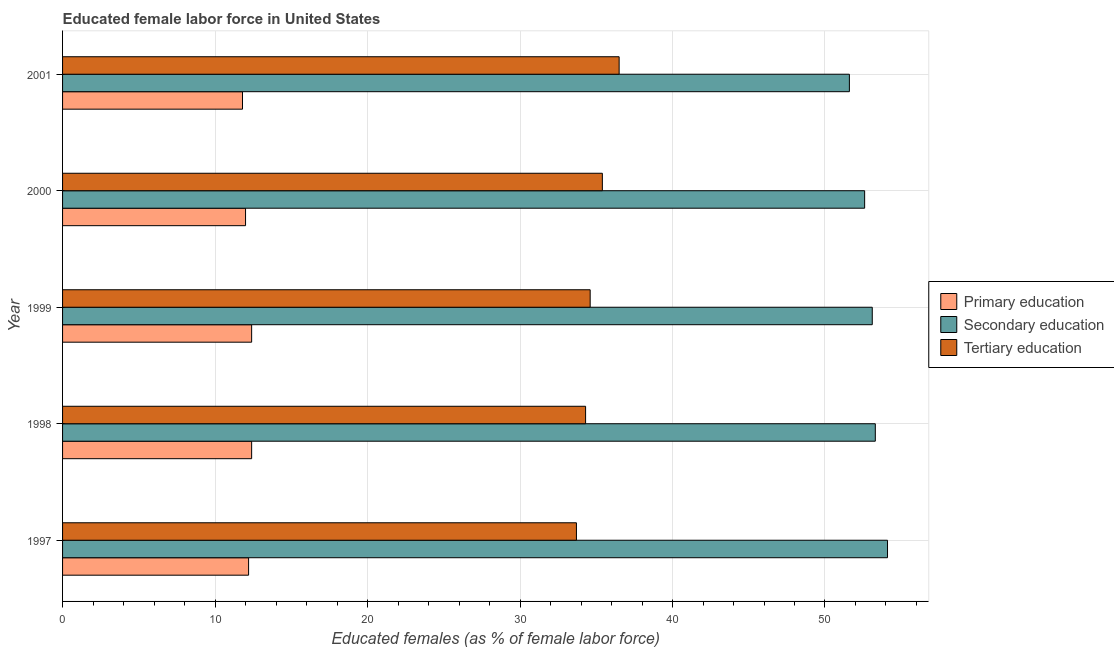How many different coloured bars are there?
Your answer should be very brief. 3. Are the number of bars per tick equal to the number of legend labels?
Provide a short and direct response. Yes. How many bars are there on the 5th tick from the top?
Your answer should be compact. 3. What is the percentage of female labor force who received secondary education in 1998?
Keep it short and to the point. 53.3. Across all years, what is the maximum percentage of female labor force who received tertiary education?
Offer a terse response. 36.5. Across all years, what is the minimum percentage of female labor force who received primary education?
Give a very brief answer. 11.8. In which year was the percentage of female labor force who received secondary education maximum?
Provide a succinct answer. 1997. In which year was the percentage of female labor force who received tertiary education minimum?
Your answer should be compact. 1997. What is the total percentage of female labor force who received secondary education in the graph?
Your answer should be very brief. 264.7. What is the difference between the percentage of female labor force who received primary education in 1997 and the percentage of female labor force who received secondary education in 1998?
Ensure brevity in your answer.  -41.1. What is the average percentage of female labor force who received primary education per year?
Your response must be concise. 12.16. In the year 1997, what is the difference between the percentage of female labor force who received primary education and percentage of female labor force who received secondary education?
Your answer should be very brief. -41.9. Is the difference between the percentage of female labor force who received primary education in 1997 and 1998 greater than the difference between the percentage of female labor force who received tertiary education in 1997 and 1998?
Provide a succinct answer. Yes. What does the 2nd bar from the bottom in 1997 represents?
Ensure brevity in your answer.  Secondary education. Is it the case that in every year, the sum of the percentage of female labor force who received primary education and percentage of female labor force who received secondary education is greater than the percentage of female labor force who received tertiary education?
Ensure brevity in your answer.  Yes. How many bars are there?
Provide a short and direct response. 15. Are all the bars in the graph horizontal?
Provide a short and direct response. Yes. What is the difference between two consecutive major ticks on the X-axis?
Give a very brief answer. 10. Are the values on the major ticks of X-axis written in scientific E-notation?
Your response must be concise. No. Does the graph contain any zero values?
Give a very brief answer. No. How many legend labels are there?
Ensure brevity in your answer.  3. How are the legend labels stacked?
Ensure brevity in your answer.  Vertical. What is the title of the graph?
Ensure brevity in your answer.  Educated female labor force in United States. What is the label or title of the X-axis?
Provide a succinct answer. Educated females (as % of female labor force). What is the label or title of the Y-axis?
Your answer should be very brief. Year. What is the Educated females (as % of female labor force) in Primary education in 1997?
Your answer should be very brief. 12.2. What is the Educated females (as % of female labor force) of Secondary education in 1997?
Your answer should be very brief. 54.1. What is the Educated females (as % of female labor force) of Tertiary education in 1997?
Your answer should be very brief. 33.7. What is the Educated females (as % of female labor force) in Primary education in 1998?
Offer a terse response. 12.4. What is the Educated females (as % of female labor force) in Secondary education in 1998?
Ensure brevity in your answer.  53.3. What is the Educated females (as % of female labor force) in Tertiary education in 1998?
Offer a very short reply. 34.3. What is the Educated females (as % of female labor force) of Primary education in 1999?
Your response must be concise. 12.4. What is the Educated females (as % of female labor force) of Secondary education in 1999?
Provide a short and direct response. 53.1. What is the Educated females (as % of female labor force) of Tertiary education in 1999?
Offer a terse response. 34.6. What is the Educated females (as % of female labor force) in Secondary education in 2000?
Offer a very short reply. 52.6. What is the Educated females (as % of female labor force) in Tertiary education in 2000?
Ensure brevity in your answer.  35.4. What is the Educated females (as % of female labor force) of Primary education in 2001?
Give a very brief answer. 11.8. What is the Educated females (as % of female labor force) of Secondary education in 2001?
Make the answer very short. 51.6. What is the Educated females (as % of female labor force) of Tertiary education in 2001?
Provide a succinct answer. 36.5. Across all years, what is the maximum Educated females (as % of female labor force) of Primary education?
Ensure brevity in your answer.  12.4. Across all years, what is the maximum Educated females (as % of female labor force) in Secondary education?
Give a very brief answer. 54.1. Across all years, what is the maximum Educated females (as % of female labor force) in Tertiary education?
Your response must be concise. 36.5. Across all years, what is the minimum Educated females (as % of female labor force) in Primary education?
Offer a terse response. 11.8. Across all years, what is the minimum Educated females (as % of female labor force) in Secondary education?
Keep it short and to the point. 51.6. Across all years, what is the minimum Educated females (as % of female labor force) in Tertiary education?
Provide a succinct answer. 33.7. What is the total Educated females (as % of female labor force) of Primary education in the graph?
Make the answer very short. 60.8. What is the total Educated females (as % of female labor force) of Secondary education in the graph?
Provide a succinct answer. 264.7. What is the total Educated females (as % of female labor force) of Tertiary education in the graph?
Your answer should be very brief. 174.5. What is the difference between the Educated females (as % of female labor force) in Primary education in 1997 and that in 1998?
Give a very brief answer. -0.2. What is the difference between the Educated females (as % of female labor force) in Secondary education in 1997 and that in 1998?
Ensure brevity in your answer.  0.8. What is the difference between the Educated females (as % of female labor force) of Tertiary education in 1997 and that in 1998?
Your answer should be compact. -0.6. What is the difference between the Educated females (as % of female labor force) of Secondary education in 1997 and that in 1999?
Ensure brevity in your answer.  1. What is the difference between the Educated females (as % of female labor force) of Primary education in 1997 and that in 2000?
Provide a short and direct response. 0.2. What is the difference between the Educated females (as % of female labor force) in Tertiary education in 1997 and that in 2000?
Give a very brief answer. -1.7. What is the difference between the Educated females (as % of female labor force) in Secondary education in 1997 and that in 2001?
Your answer should be very brief. 2.5. What is the difference between the Educated females (as % of female labor force) of Tertiary education in 1997 and that in 2001?
Make the answer very short. -2.8. What is the difference between the Educated females (as % of female labor force) of Tertiary education in 1998 and that in 1999?
Give a very brief answer. -0.3. What is the difference between the Educated females (as % of female labor force) of Secondary education in 1998 and that in 2000?
Your answer should be compact. 0.7. What is the difference between the Educated females (as % of female labor force) of Tertiary education in 1998 and that in 2000?
Your answer should be compact. -1.1. What is the difference between the Educated females (as % of female labor force) in Secondary education in 1998 and that in 2001?
Offer a very short reply. 1.7. What is the difference between the Educated females (as % of female labor force) of Tertiary education in 1998 and that in 2001?
Offer a terse response. -2.2. What is the difference between the Educated females (as % of female labor force) in Tertiary education in 1999 and that in 2000?
Make the answer very short. -0.8. What is the difference between the Educated females (as % of female labor force) of Primary education in 1999 and that in 2001?
Provide a succinct answer. 0.6. What is the difference between the Educated females (as % of female labor force) in Tertiary education in 1999 and that in 2001?
Ensure brevity in your answer.  -1.9. What is the difference between the Educated females (as % of female labor force) of Primary education in 2000 and that in 2001?
Make the answer very short. 0.2. What is the difference between the Educated females (as % of female labor force) of Primary education in 1997 and the Educated females (as % of female labor force) of Secondary education in 1998?
Provide a short and direct response. -41.1. What is the difference between the Educated females (as % of female labor force) in Primary education in 1997 and the Educated females (as % of female labor force) in Tertiary education in 1998?
Provide a succinct answer. -22.1. What is the difference between the Educated females (as % of female labor force) of Secondary education in 1997 and the Educated females (as % of female labor force) of Tertiary education in 1998?
Give a very brief answer. 19.8. What is the difference between the Educated females (as % of female labor force) in Primary education in 1997 and the Educated females (as % of female labor force) in Secondary education in 1999?
Your answer should be compact. -40.9. What is the difference between the Educated females (as % of female labor force) of Primary education in 1997 and the Educated females (as % of female labor force) of Tertiary education in 1999?
Provide a short and direct response. -22.4. What is the difference between the Educated females (as % of female labor force) of Primary education in 1997 and the Educated females (as % of female labor force) of Secondary education in 2000?
Make the answer very short. -40.4. What is the difference between the Educated females (as % of female labor force) of Primary education in 1997 and the Educated females (as % of female labor force) of Tertiary education in 2000?
Your answer should be very brief. -23.2. What is the difference between the Educated females (as % of female labor force) of Secondary education in 1997 and the Educated females (as % of female labor force) of Tertiary education in 2000?
Your answer should be very brief. 18.7. What is the difference between the Educated females (as % of female labor force) of Primary education in 1997 and the Educated females (as % of female labor force) of Secondary education in 2001?
Your response must be concise. -39.4. What is the difference between the Educated females (as % of female labor force) in Primary education in 1997 and the Educated females (as % of female labor force) in Tertiary education in 2001?
Your response must be concise. -24.3. What is the difference between the Educated females (as % of female labor force) of Secondary education in 1997 and the Educated females (as % of female labor force) of Tertiary education in 2001?
Make the answer very short. 17.6. What is the difference between the Educated females (as % of female labor force) of Primary education in 1998 and the Educated females (as % of female labor force) of Secondary education in 1999?
Offer a terse response. -40.7. What is the difference between the Educated females (as % of female labor force) in Primary education in 1998 and the Educated females (as % of female labor force) in Tertiary education in 1999?
Your answer should be compact. -22.2. What is the difference between the Educated females (as % of female labor force) of Secondary education in 1998 and the Educated females (as % of female labor force) of Tertiary education in 1999?
Offer a terse response. 18.7. What is the difference between the Educated females (as % of female labor force) of Primary education in 1998 and the Educated females (as % of female labor force) of Secondary education in 2000?
Give a very brief answer. -40.2. What is the difference between the Educated females (as % of female labor force) of Secondary education in 1998 and the Educated females (as % of female labor force) of Tertiary education in 2000?
Make the answer very short. 17.9. What is the difference between the Educated females (as % of female labor force) of Primary education in 1998 and the Educated females (as % of female labor force) of Secondary education in 2001?
Offer a terse response. -39.2. What is the difference between the Educated females (as % of female labor force) in Primary education in 1998 and the Educated females (as % of female labor force) in Tertiary education in 2001?
Provide a short and direct response. -24.1. What is the difference between the Educated females (as % of female labor force) of Secondary education in 1998 and the Educated females (as % of female labor force) of Tertiary education in 2001?
Provide a short and direct response. 16.8. What is the difference between the Educated females (as % of female labor force) in Primary education in 1999 and the Educated females (as % of female labor force) in Secondary education in 2000?
Offer a very short reply. -40.2. What is the difference between the Educated females (as % of female labor force) of Primary education in 1999 and the Educated females (as % of female labor force) of Secondary education in 2001?
Provide a short and direct response. -39.2. What is the difference between the Educated females (as % of female labor force) of Primary education in 1999 and the Educated females (as % of female labor force) of Tertiary education in 2001?
Offer a very short reply. -24.1. What is the difference between the Educated females (as % of female labor force) in Secondary education in 1999 and the Educated females (as % of female labor force) in Tertiary education in 2001?
Provide a succinct answer. 16.6. What is the difference between the Educated females (as % of female labor force) of Primary education in 2000 and the Educated females (as % of female labor force) of Secondary education in 2001?
Your response must be concise. -39.6. What is the difference between the Educated females (as % of female labor force) of Primary education in 2000 and the Educated females (as % of female labor force) of Tertiary education in 2001?
Ensure brevity in your answer.  -24.5. What is the difference between the Educated females (as % of female labor force) in Secondary education in 2000 and the Educated females (as % of female labor force) in Tertiary education in 2001?
Offer a terse response. 16.1. What is the average Educated females (as % of female labor force) of Primary education per year?
Your response must be concise. 12.16. What is the average Educated females (as % of female labor force) of Secondary education per year?
Give a very brief answer. 52.94. What is the average Educated females (as % of female labor force) of Tertiary education per year?
Your answer should be compact. 34.9. In the year 1997, what is the difference between the Educated females (as % of female labor force) in Primary education and Educated females (as % of female labor force) in Secondary education?
Offer a very short reply. -41.9. In the year 1997, what is the difference between the Educated females (as % of female labor force) in Primary education and Educated females (as % of female labor force) in Tertiary education?
Offer a terse response. -21.5. In the year 1997, what is the difference between the Educated females (as % of female labor force) in Secondary education and Educated females (as % of female labor force) in Tertiary education?
Offer a terse response. 20.4. In the year 1998, what is the difference between the Educated females (as % of female labor force) of Primary education and Educated females (as % of female labor force) of Secondary education?
Offer a terse response. -40.9. In the year 1998, what is the difference between the Educated females (as % of female labor force) in Primary education and Educated females (as % of female labor force) in Tertiary education?
Offer a terse response. -21.9. In the year 1999, what is the difference between the Educated females (as % of female labor force) in Primary education and Educated females (as % of female labor force) in Secondary education?
Offer a very short reply. -40.7. In the year 1999, what is the difference between the Educated females (as % of female labor force) in Primary education and Educated females (as % of female labor force) in Tertiary education?
Ensure brevity in your answer.  -22.2. In the year 2000, what is the difference between the Educated females (as % of female labor force) in Primary education and Educated females (as % of female labor force) in Secondary education?
Keep it short and to the point. -40.6. In the year 2000, what is the difference between the Educated females (as % of female labor force) of Primary education and Educated females (as % of female labor force) of Tertiary education?
Your answer should be compact. -23.4. In the year 2001, what is the difference between the Educated females (as % of female labor force) of Primary education and Educated females (as % of female labor force) of Secondary education?
Offer a terse response. -39.8. In the year 2001, what is the difference between the Educated females (as % of female labor force) in Primary education and Educated females (as % of female labor force) in Tertiary education?
Your answer should be compact. -24.7. In the year 2001, what is the difference between the Educated females (as % of female labor force) of Secondary education and Educated females (as % of female labor force) of Tertiary education?
Your response must be concise. 15.1. What is the ratio of the Educated females (as % of female labor force) of Primary education in 1997 to that in 1998?
Your answer should be very brief. 0.98. What is the ratio of the Educated females (as % of female labor force) of Tertiary education in 1997 to that in 1998?
Give a very brief answer. 0.98. What is the ratio of the Educated females (as % of female labor force) in Primary education in 1997 to that in 1999?
Your answer should be compact. 0.98. What is the ratio of the Educated females (as % of female labor force) of Secondary education in 1997 to that in 1999?
Offer a very short reply. 1.02. What is the ratio of the Educated females (as % of female labor force) of Tertiary education in 1997 to that in 1999?
Provide a short and direct response. 0.97. What is the ratio of the Educated females (as % of female labor force) of Primary education in 1997 to that in 2000?
Give a very brief answer. 1.02. What is the ratio of the Educated females (as % of female labor force) of Secondary education in 1997 to that in 2000?
Give a very brief answer. 1.03. What is the ratio of the Educated females (as % of female labor force) in Primary education in 1997 to that in 2001?
Make the answer very short. 1.03. What is the ratio of the Educated females (as % of female labor force) in Secondary education in 1997 to that in 2001?
Give a very brief answer. 1.05. What is the ratio of the Educated females (as % of female labor force) of Tertiary education in 1997 to that in 2001?
Provide a succinct answer. 0.92. What is the ratio of the Educated females (as % of female labor force) of Primary education in 1998 to that in 1999?
Ensure brevity in your answer.  1. What is the ratio of the Educated females (as % of female labor force) of Secondary education in 1998 to that in 1999?
Give a very brief answer. 1. What is the ratio of the Educated females (as % of female labor force) of Primary education in 1998 to that in 2000?
Give a very brief answer. 1.03. What is the ratio of the Educated females (as % of female labor force) in Secondary education in 1998 to that in 2000?
Keep it short and to the point. 1.01. What is the ratio of the Educated females (as % of female labor force) in Tertiary education in 1998 to that in 2000?
Your answer should be very brief. 0.97. What is the ratio of the Educated females (as % of female labor force) of Primary education in 1998 to that in 2001?
Keep it short and to the point. 1.05. What is the ratio of the Educated females (as % of female labor force) of Secondary education in 1998 to that in 2001?
Give a very brief answer. 1.03. What is the ratio of the Educated females (as % of female labor force) in Tertiary education in 1998 to that in 2001?
Your answer should be compact. 0.94. What is the ratio of the Educated females (as % of female labor force) in Primary education in 1999 to that in 2000?
Your answer should be very brief. 1.03. What is the ratio of the Educated females (as % of female labor force) in Secondary education in 1999 to that in 2000?
Give a very brief answer. 1.01. What is the ratio of the Educated females (as % of female labor force) of Tertiary education in 1999 to that in 2000?
Give a very brief answer. 0.98. What is the ratio of the Educated females (as % of female labor force) of Primary education in 1999 to that in 2001?
Keep it short and to the point. 1.05. What is the ratio of the Educated females (as % of female labor force) in Secondary education in 1999 to that in 2001?
Provide a succinct answer. 1.03. What is the ratio of the Educated females (as % of female labor force) in Tertiary education in 1999 to that in 2001?
Offer a terse response. 0.95. What is the ratio of the Educated females (as % of female labor force) of Primary education in 2000 to that in 2001?
Your response must be concise. 1.02. What is the ratio of the Educated females (as % of female labor force) of Secondary education in 2000 to that in 2001?
Offer a very short reply. 1.02. What is the ratio of the Educated females (as % of female labor force) of Tertiary education in 2000 to that in 2001?
Ensure brevity in your answer.  0.97. What is the difference between the highest and the second highest Educated females (as % of female labor force) of Tertiary education?
Make the answer very short. 1.1. What is the difference between the highest and the lowest Educated females (as % of female labor force) of Secondary education?
Your answer should be very brief. 2.5. 